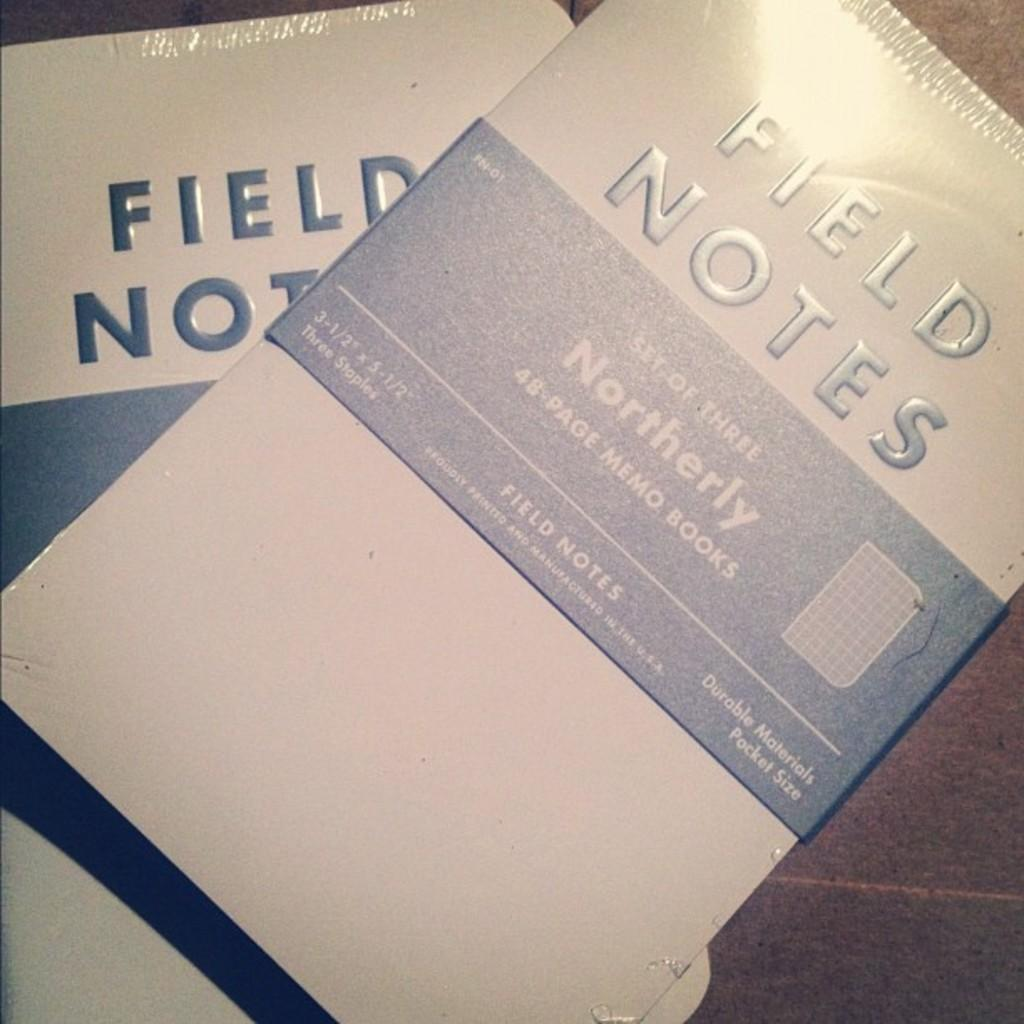<image>
Provide a brief description of the given image. Note book called Field Notes on top of a table. 